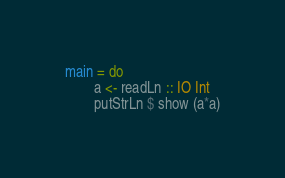<code> <loc_0><loc_0><loc_500><loc_500><_Haskell_>main = do
        a <- readLn :: IO Int
        putStrLn $ show (a*a)
</code> 